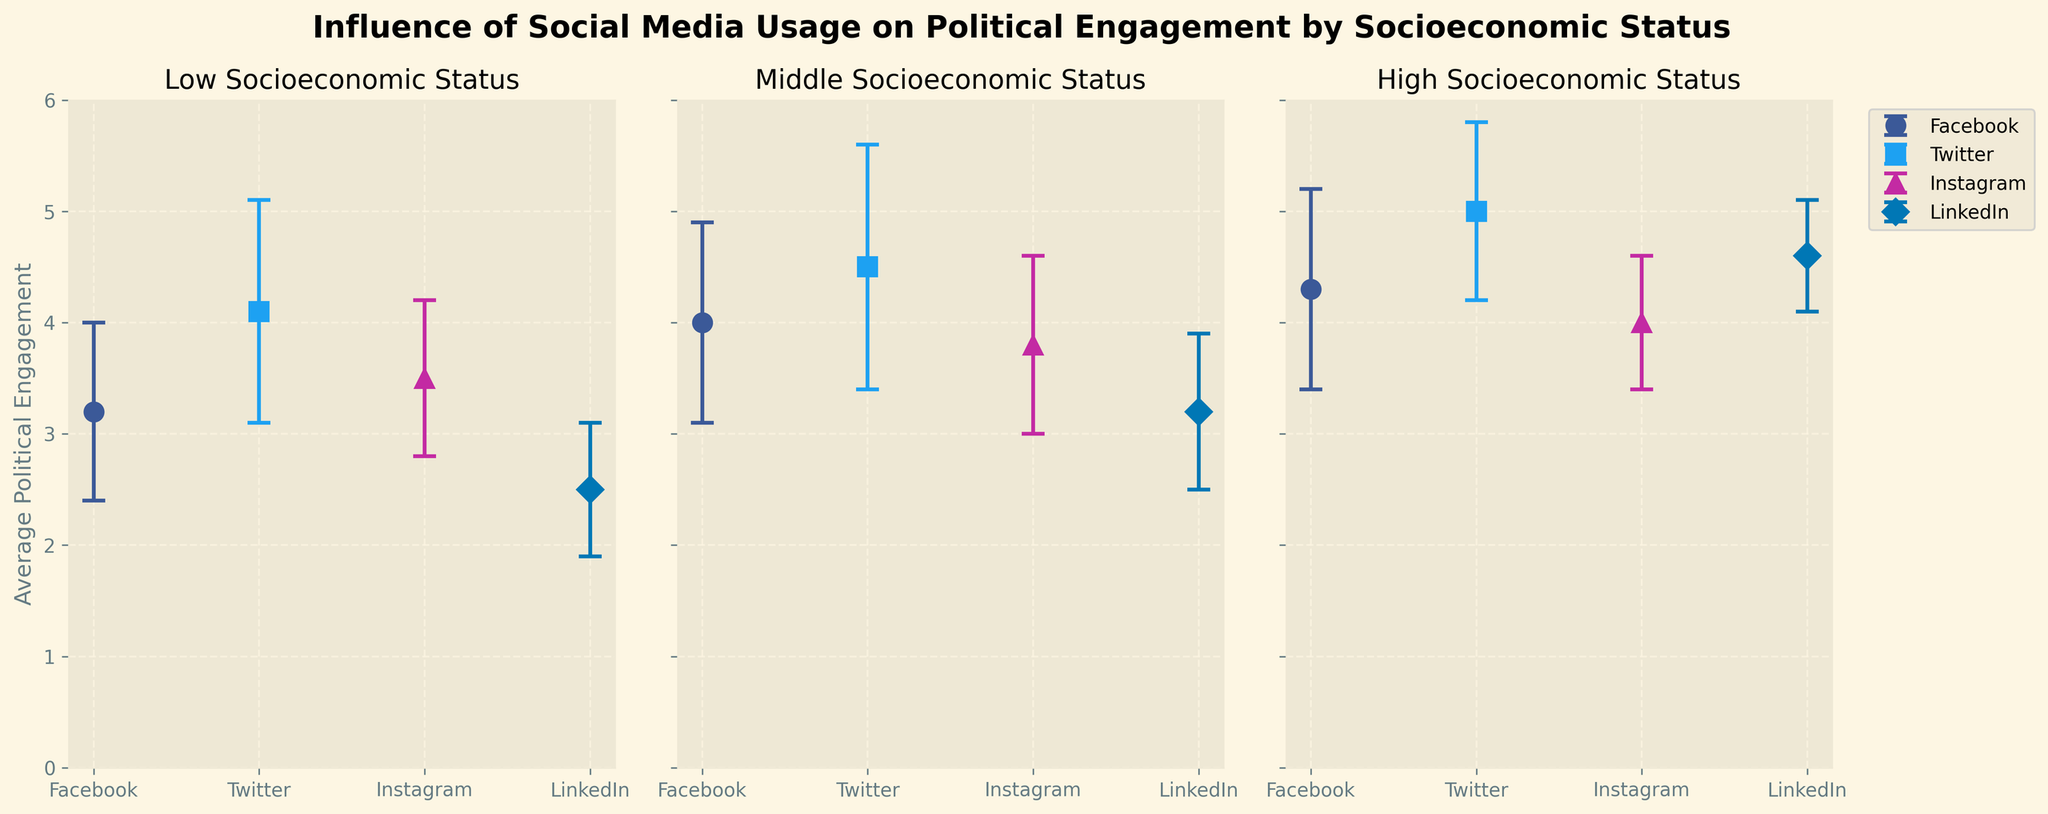What is the title of the figure? The title is displayed at the top of the figure in bold, larger font. It summarizes the information depicted in the figure.
Answer: Influence of Social Media Usage on Political Engagement by Socioeconomic Status How many socioeconomic status categories are shown in the figure? By looking at the figure, you can see three separate subplots, each with its own title indicating the socioeconomic status group.
Answer: 3 Which social media platform has the highest average political engagement for the Low socioeconomic status group? By referring to the specific subplot for the Low socioeconomic status group, compare the average political engagement values for each platform. The highest is Twitter.
Answer: Twitter What is the range of political engagement for Facebook users in the Middle socioeconomic status group? The range can be calculated by adding and subtracting the standard deviation from the average political engagement. For Facebook in the Middle socioeconomic status group, it is 4.0 ± 0.9.
Answer: [3.1, 4.9] Which social media platform shows the largest error bar for the High socioeconomic status group? Error bars represent the standard deviation. Look at the subplot for the High socioeconomic status group and compare the error bars' lengths.
Answer: Twitter Compare the average political engagement between LinkedIn users of Low and Middle socioeconomic statuses. Which group is higher and by how much? For Low, the average is 2.5, and for Middle, it is 3.2. Subtract the former from the latter to find the difference.
Answer: Middle is higher by 0.7 Rank the social media platforms by average political engagement for the High socioeconomic status group from highest to lowest. Look at the High socioeconomic status subplot and list the platforms in descending order of their average political engagement.
Answer: Twitter, LinkedIn, Facebook, Instagram Which platform shows the smallest average political engagement for the Low socioeconomic status group? By examining the subplot for the Low socioeconomic status group, identify the platform with the smallest average political engagement value.
Answer: LinkedIn What is the average standard deviation for all the social media platforms in the figure? Sum the standard deviations for all platforms across all socioeconomic groups and divide by the total number of entries. (0.8+1.0+0.7+0.6+0.9+1.1+0.8+0.7+0.9+0.8+0.6+0.5) / 12
Answer: 0.75 For Middle socioeconomic status, which platform has a higher political engagement: Facebook or Instagram, and by how much? Compare the average political engagement values for Facebook (4.0) and Instagram (3.8) in the Middle group. Subtract Instagram's value from Facebook's.
Answer: Facebook by 0.2 